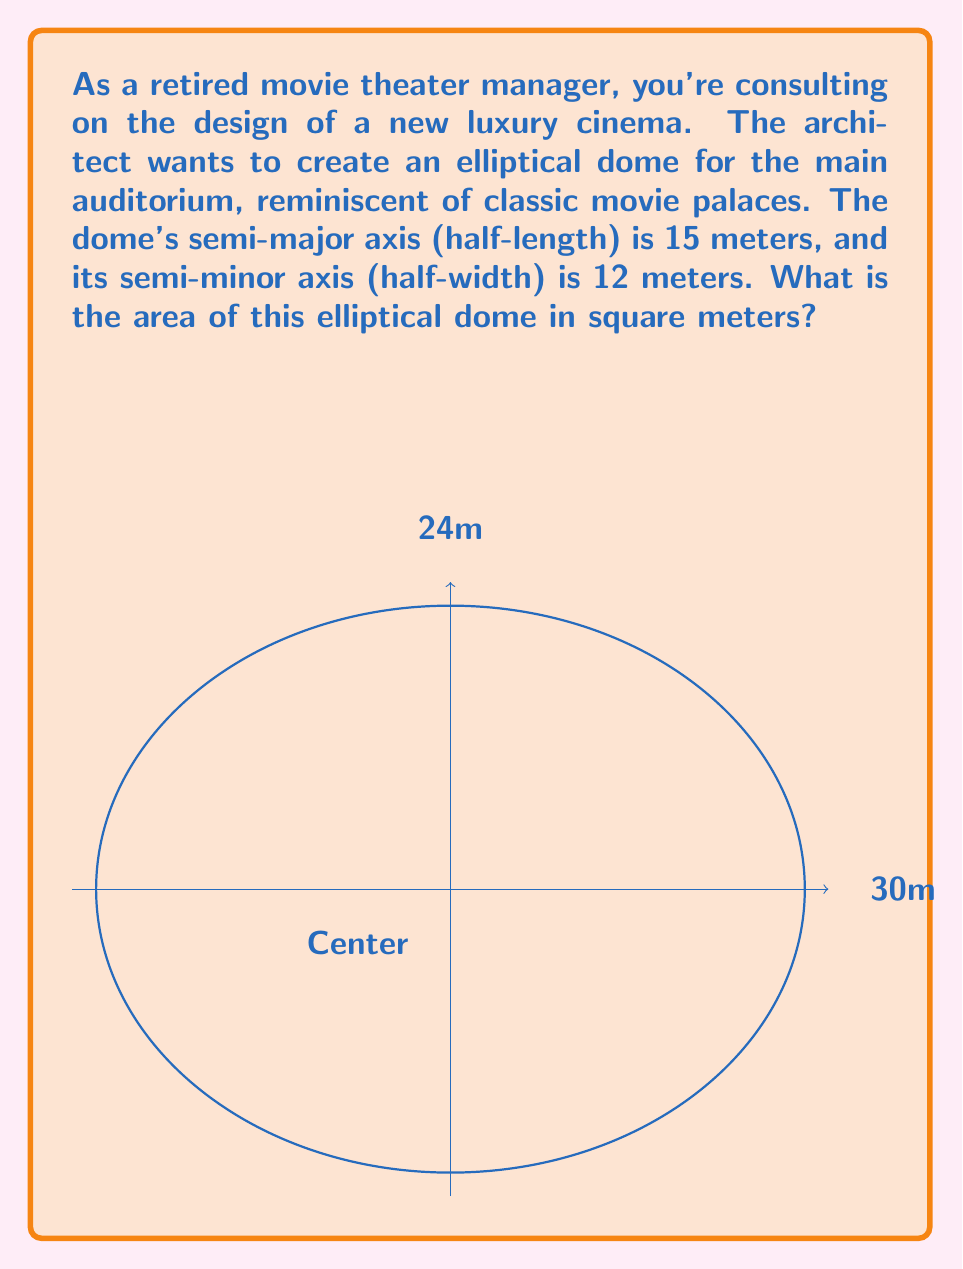Solve this math problem. Let's approach this step-by-step:

1) The formula for the area of an ellipse is:

   $$A = \pi ab$$

   where $a$ is the semi-major axis and $b$ is the semi-minor axis.

2) From the question, we know:
   $a = 15$ meters (half of 30m)
   $b = 12$ meters (half of 24m)

3) Substituting these values into our formula:

   $$A = \pi (15)(12)$$

4) Simplify:
   $$A = 180\pi$$

5) If we want to calculate the exact value:
   $$A = 180 \pi \approx 565.49 \text{ m}^2$$

The area of the elliptical dome is $180\pi$ square meters, or approximately 565.49 square meters.
Answer: $180\pi \text{ m}^2$ or approximately 565.49 $\text{m}^2$ 